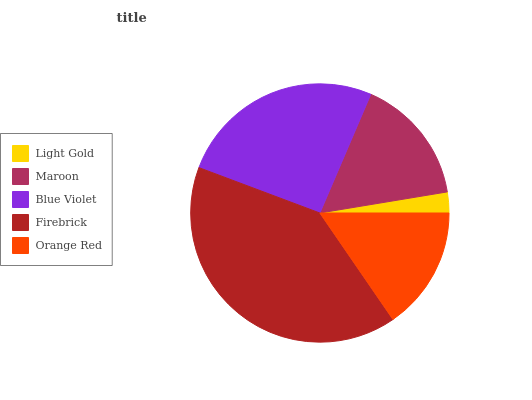Is Light Gold the minimum?
Answer yes or no. Yes. Is Firebrick the maximum?
Answer yes or no. Yes. Is Maroon the minimum?
Answer yes or no. No. Is Maroon the maximum?
Answer yes or no. No. Is Maroon greater than Light Gold?
Answer yes or no. Yes. Is Light Gold less than Maroon?
Answer yes or no. Yes. Is Light Gold greater than Maroon?
Answer yes or no. No. Is Maroon less than Light Gold?
Answer yes or no. No. Is Maroon the high median?
Answer yes or no. Yes. Is Maroon the low median?
Answer yes or no. Yes. Is Firebrick the high median?
Answer yes or no. No. Is Blue Violet the low median?
Answer yes or no. No. 